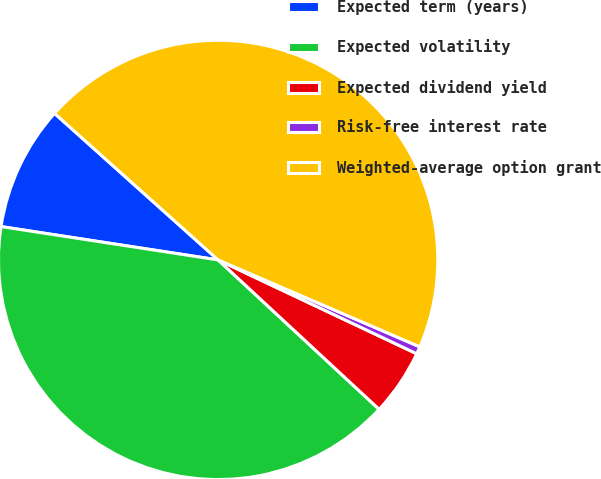Convert chart to OTSL. <chart><loc_0><loc_0><loc_500><loc_500><pie_chart><fcel>Expected term (years)<fcel>Expected volatility<fcel>Expected dividend yield<fcel>Risk-free interest rate<fcel>Weighted-average option grant<nl><fcel>9.2%<fcel>40.52%<fcel>4.88%<fcel>0.55%<fcel>44.85%<nl></chart> 